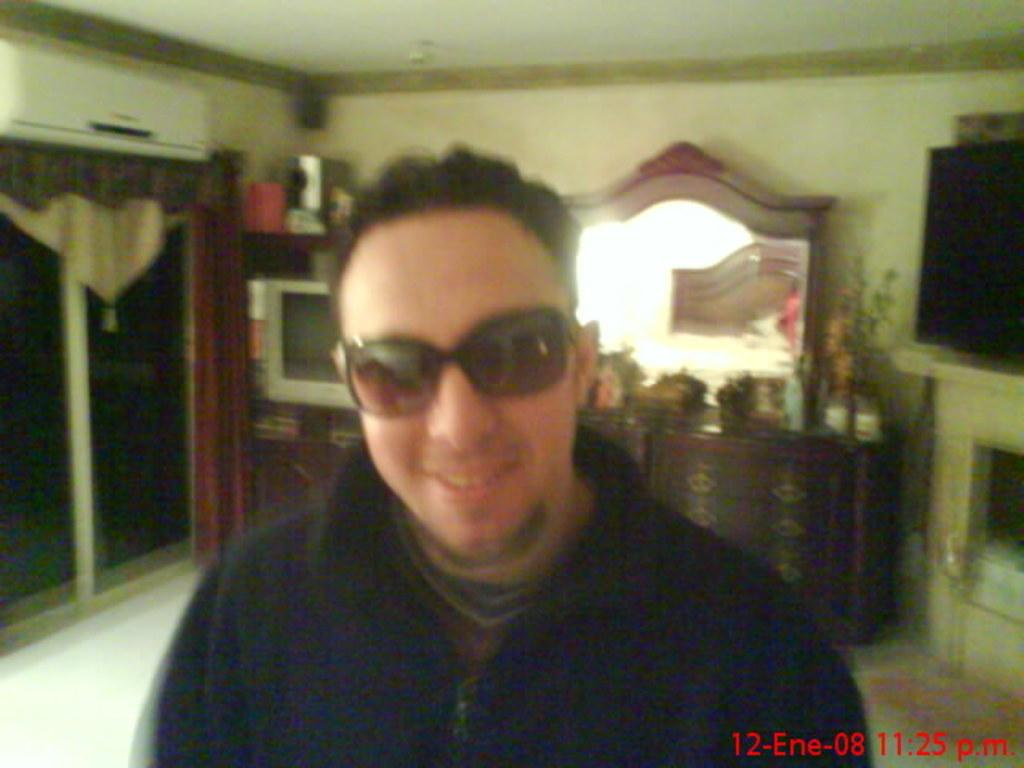What is the main subject of the image? There is a man in the image. What is the man wearing on his face? The man is wearing goggles. What expression does the man have? The man is smiling. What can be seen in the background of the image? There is a window with curtains, a television, a mirror, and some objects in the background of the image. What type of glove is the man wearing in the image? There is no glove visible on the man in the image; he is wearing goggles. Can you describe the branch that is supporting the man in the image? There is no branch present in the image; the man is standing on the ground. 